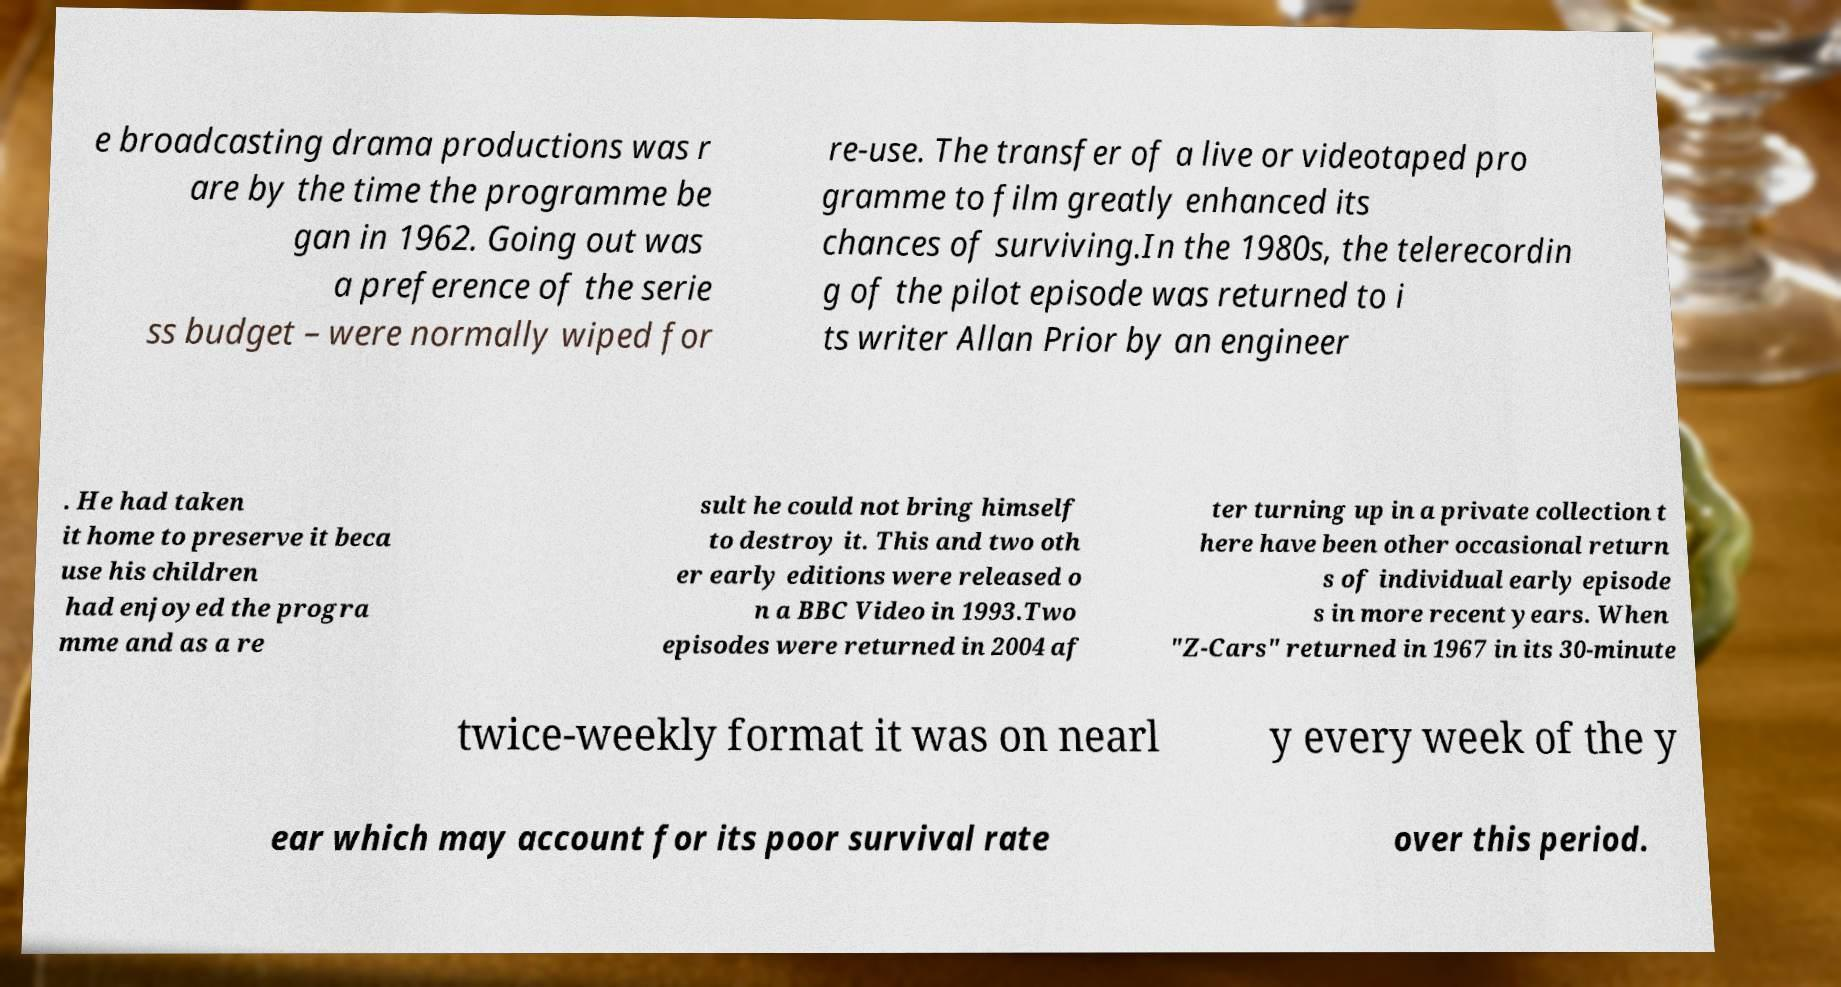Can you read and provide the text displayed in the image?This photo seems to have some interesting text. Can you extract and type it out for me? e broadcasting drama productions was r are by the time the programme be gan in 1962. Going out was a preference of the serie ss budget – were normally wiped for re-use. The transfer of a live or videotaped pro gramme to film greatly enhanced its chances of surviving.In the 1980s, the telerecordin g of the pilot episode was returned to i ts writer Allan Prior by an engineer . He had taken it home to preserve it beca use his children had enjoyed the progra mme and as a re sult he could not bring himself to destroy it. This and two oth er early editions were released o n a BBC Video in 1993.Two episodes were returned in 2004 af ter turning up in a private collection t here have been other occasional return s of individual early episode s in more recent years. When "Z-Cars" returned in 1967 in its 30-minute twice-weekly format it was on nearl y every week of the y ear which may account for its poor survival rate over this period. 